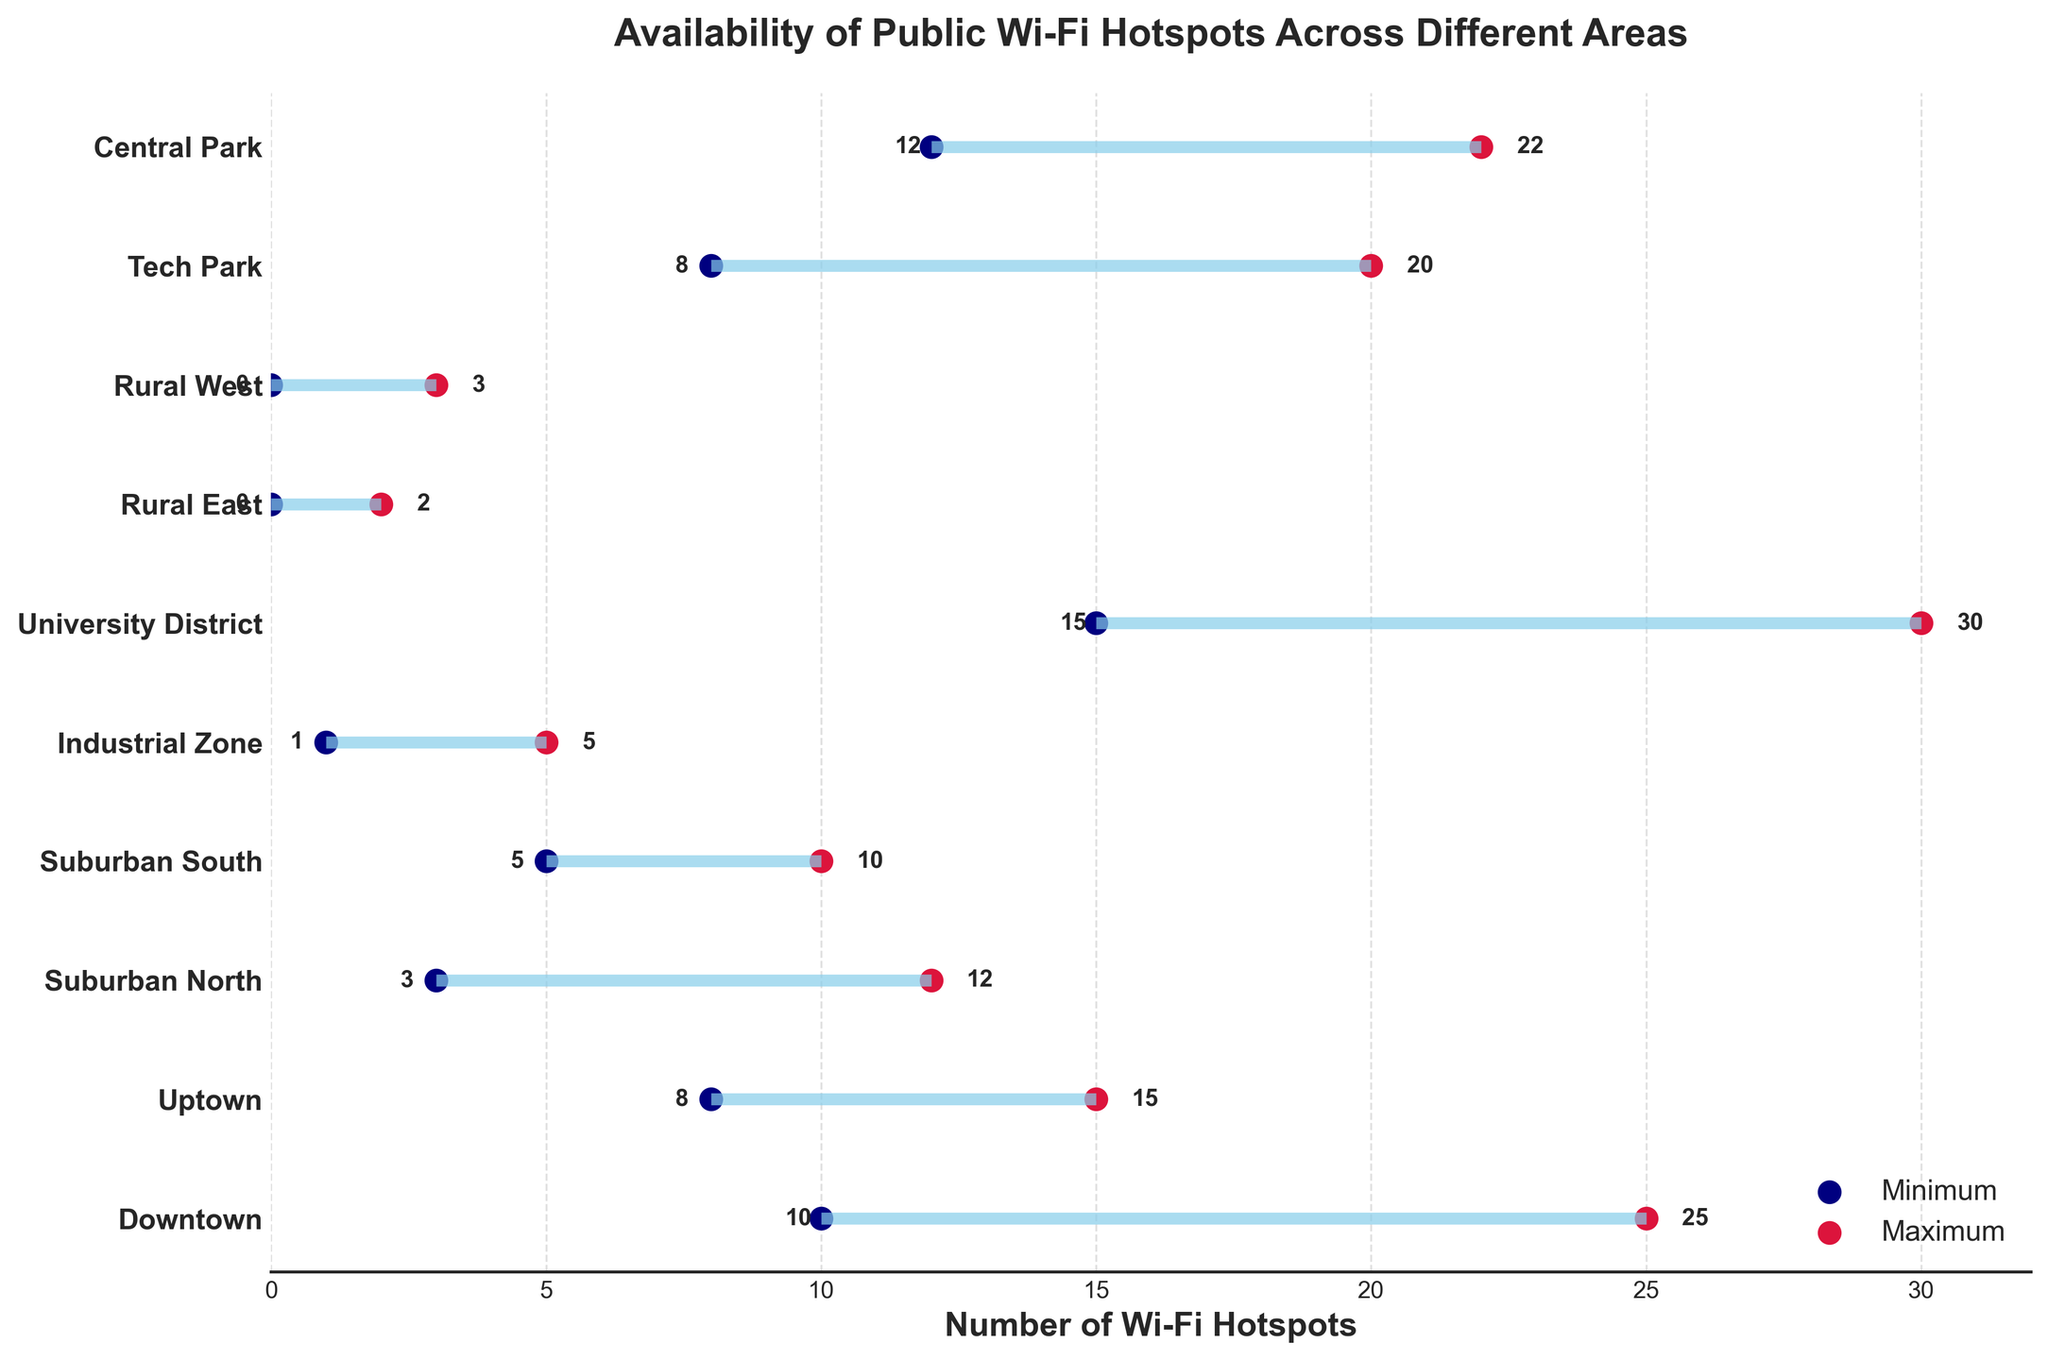What is the title of the plot? The title of the plot is usually displayed at the top center of the plot and it tells us the main topic or focus of the visual representation. In this case, it is clearly mentioned.
Answer: "Availability of Public Wi-Fi Hotspots Across Different Areas" How many areas are compared in this plot? Count the number of y-axis labels, which represent the different areas in the constituency. Each label corresponds to an area.
Answer: 10 Which area has the highest maximum number of Wi-Fi hotspots? Look at the red dots representing the maximum number of hotspots for each area. The area with the red dot farthest to the right has the highest maximum number of Wi-Fi hotspots.
Answer: University District Which area has the smallest range of Wi-Fi hotspots availability? To find the smallest range, look at the horizontal lines and compare their lengths. The shortest line represents the area with the smallest range.
Answer: Rural East How does the availability of Wi-Fi hotspots in Downtown compare to Uptown? Compare both the minimum and maximum values for Downtown and Uptown. Downtown has a minimum of 10 and a maximum of 25, whereas Uptown has a minimum of 8 and a maximum of 15.
Answer: Downtown has more What is the average maximum number of Wi-Fi hotspots available across all areas? Sum all the maximum values and then divide by the number of areas (10). Average = (25+15+12+10+5+30+2+3+20+22)/10
Answer: 14.4 Which areas have the minimum number of Wi-Fi hotspots equal to zero? Look for the blue dots positioned at 0 on the x-axis. The corresponding y-axis labels will indicate the areas.
Answer: Rural East, Rural West What is the combined range of Wi-Fi hotspots availability in Suburban North and Suburban South? Find the ranges by subtracting the minimum from the maximum for both Suburban North (12-3) and Suburban South (10-5), then sum the ranges. Combined range = (12-3) + (10-5) = 9 + 5
Answer: 14 Which area has both the minimum and maximum values of Wi-Fi hotspots within the top half (greater than or equal to 10)? Identify areas where both the blue and red dots are positioned at or above 10 on the x-axis.
Answer: Central Park In which area is the gap between the minimum and maximum number of Wi-Fi hotspots the greatest? Calculate the difference between the maximum and minimum for each area and determine which has the largest difference. University District has a range of (30-15) = 15 which is the largest.
Answer: University District 